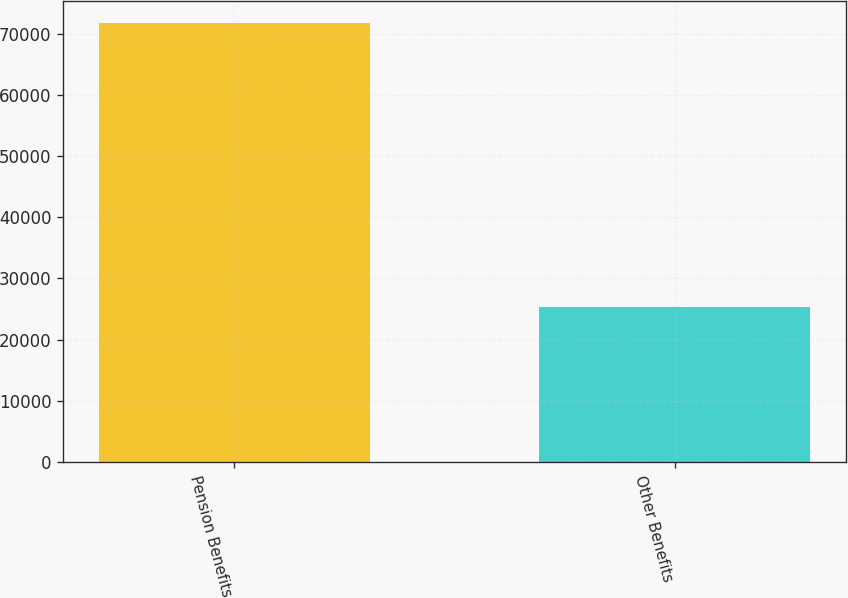Convert chart to OTSL. <chart><loc_0><loc_0><loc_500><loc_500><bar_chart><fcel>Pension Benefits<fcel>Other Benefits<nl><fcel>71685<fcel>25247<nl></chart> 